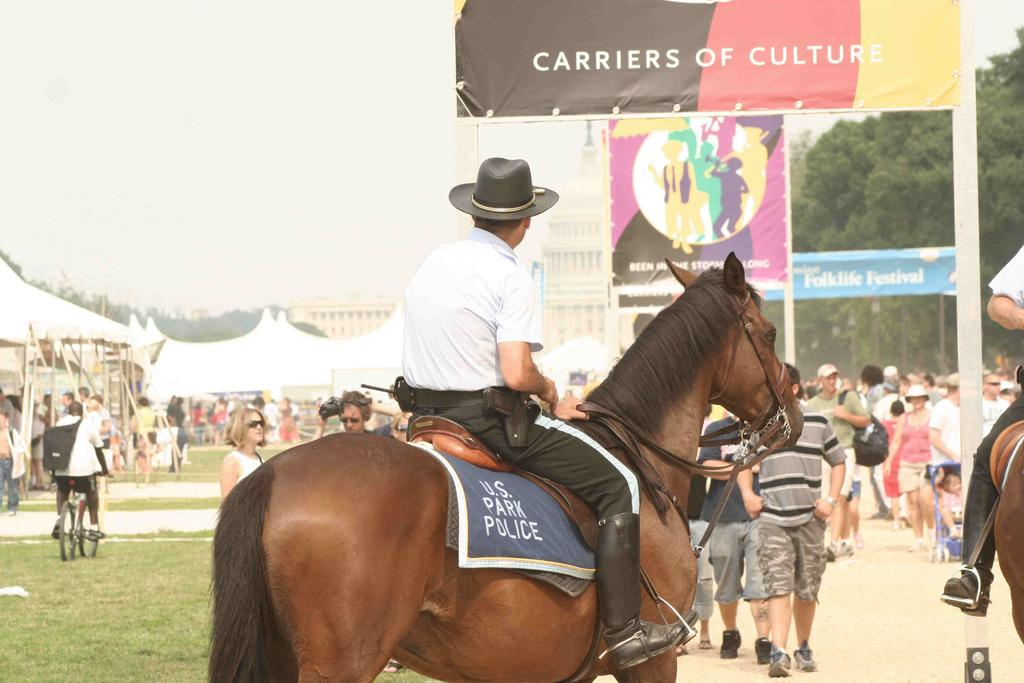What is the man in the image doing? The man is sitting on a horse in the image. What can be seen in the background of the image? There are people, tents, a building, trees, and banners in the background of the image. How many structures are visible in the background of the image? There is at least one building visible in the background of the image. Is the horse sinking into quicksand in the image? No, there is no quicksand present in the image. How many fingers can be seen on the man's hand in the image? There is no visible hand or fingers on the man in the image. 